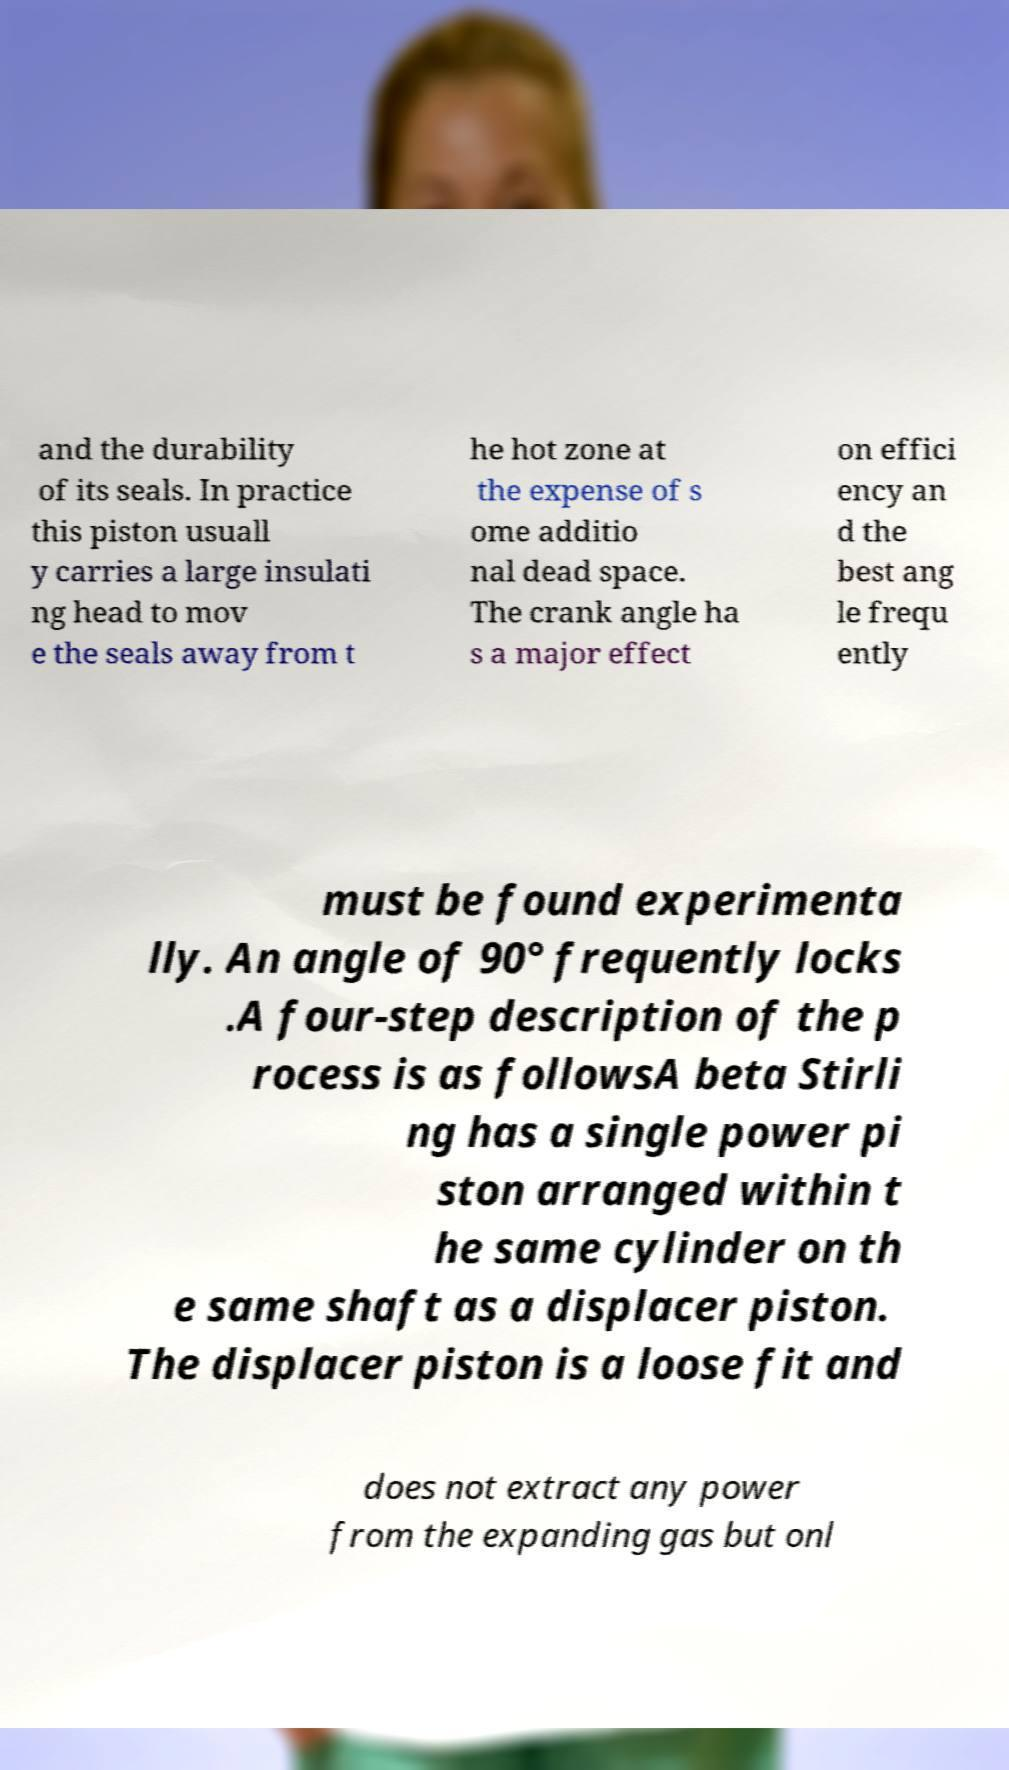I need the written content from this picture converted into text. Can you do that? and the durability of its seals. In practice this piston usuall y carries a large insulati ng head to mov e the seals away from t he hot zone at the expense of s ome additio nal dead space. The crank angle ha s a major effect on effici ency an d the best ang le frequ ently must be found experimenta lly. An angle of 90° frequently locks .A four-step description of the p rocess is as followsA beta Stirli ng has a single power pi ston arranged within t he same cylinder on th e same shaft as a displacer piston. The displacer piston is a loose fit and does not extract any power from the expanding gas but onl 